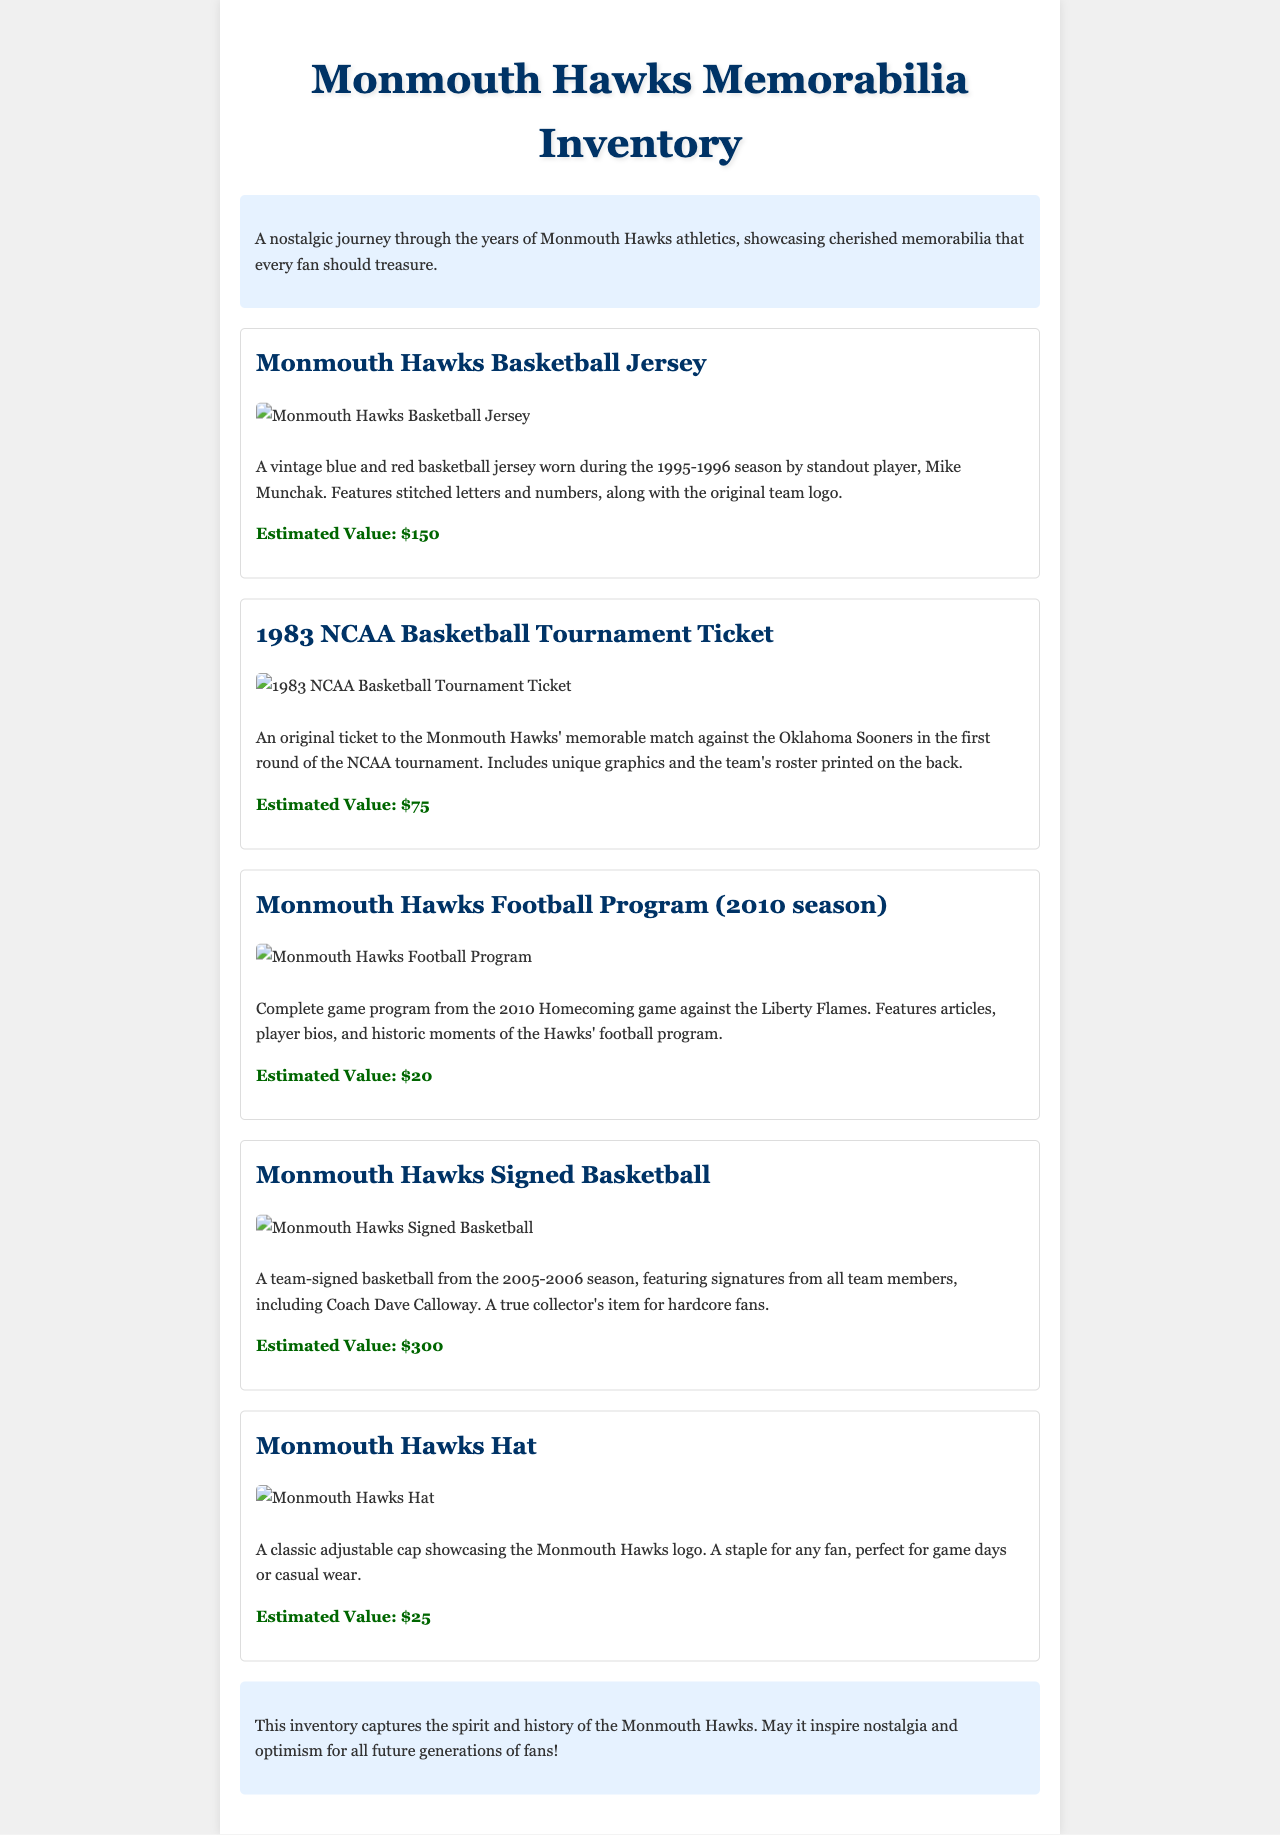what year was the basketball jersey worn? The basketball jersey was worn during the 1995-1996 season, as stated in the document.
Answer: 1995-1996 who was the standout player associated with the jersey? The standout player associated with the jersey is Mike Munchak, mentioned in the description.
Answer: Mike Munchak what is the estimated value of the signed basketball? The estimated value for the signed basketball is provided in the document as $300.
Answer: $300 how many memorabilia items are illustrated in the document? The document contains five distinct memorabilia items, each listed with a description and value.
Answer: five what is the title of the document? The title of the document is found at the top, reflecting the content it covers.
Answer: Monmouth Hawks Memorabilia Inventory which season is highlighted in the football program? The football program highlighted in the document is for the 2010 season, specified in the program description.
Answer: 2010 season what type of item is the NCAA Basketball Tournament ticket? The document categorizes the ticket as a specific event memorabilia related to basketball.
Answer: Event ticket why might the signed basketball be considered a collector's item? The signed basketball is considered a collector's item because it features signatures from all team members and the coach.
Answer: Team-signed basketball what color scheme does the basketball jersey feature? The basketball jersey is described as vintage blue and red, indicating its color scheme.
Answer: Blue and red 